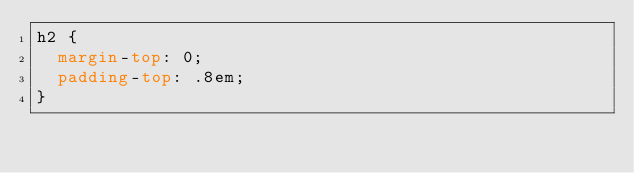<code> <loc_0><loc_0><loc_500><loc_500><_CSS_>h2 {
  margin-top: 0;
  padding-top: .8em;
}
</code> 